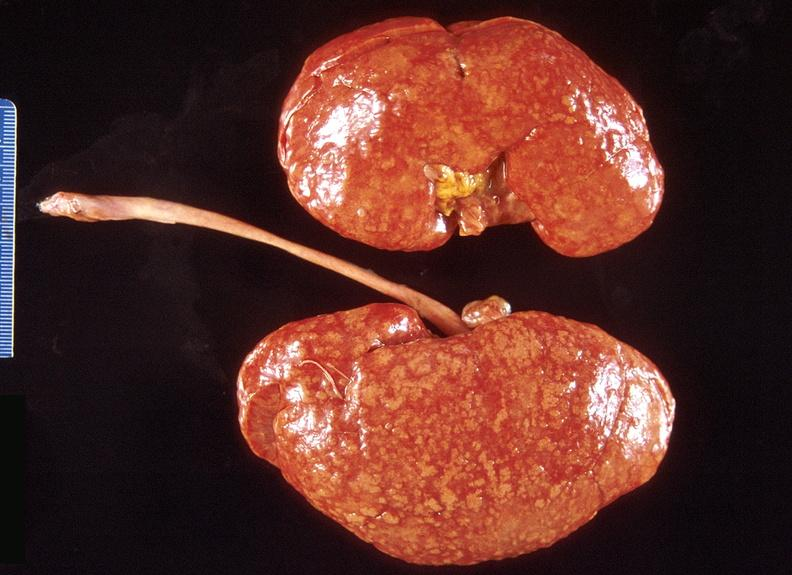does this image show kidney, obliterative endarteritis - sclerodema?
Answer the question using a single word or phrase. Yes 